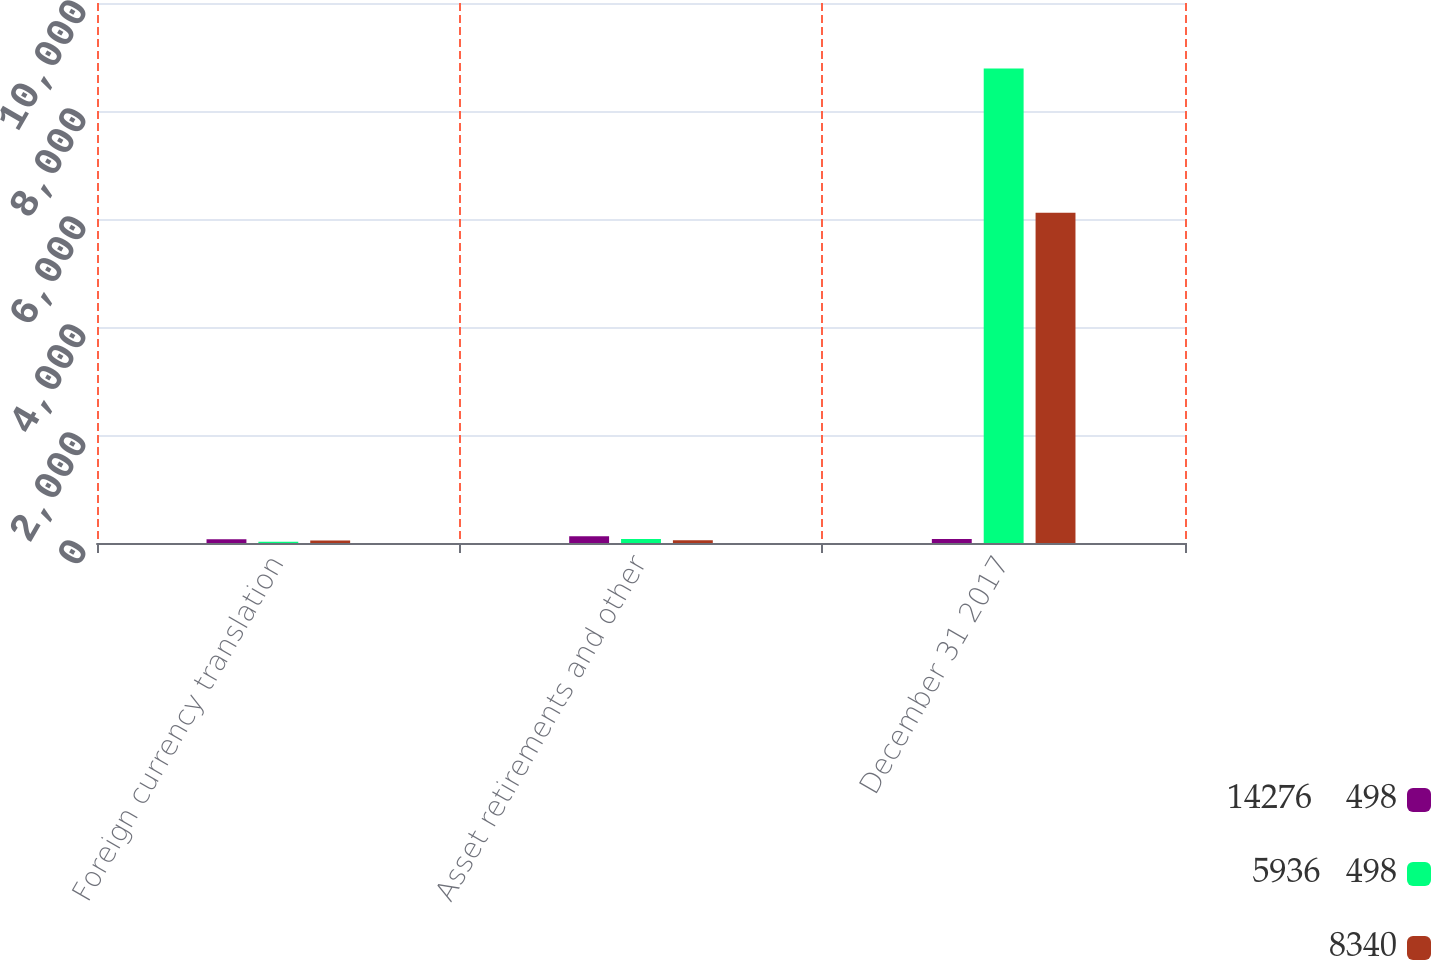Convert chart to OTSL. <chart><loc_0><loc_0><loc_500><loc_500><stacked_bar_chart><ecel><fcel>Foreign currency translation<fcel>Asset retirements and other<fcel>December 31 2017<nl><fcel>14276    498<fcel>71<fcel>125<fcel>72.5<nl><fcel>5936   498<fcel>25<fcel>74<fcel>8788<nl><fcel>8340<fcel>46<fcel>51<fcel>6116<nl></chart> 